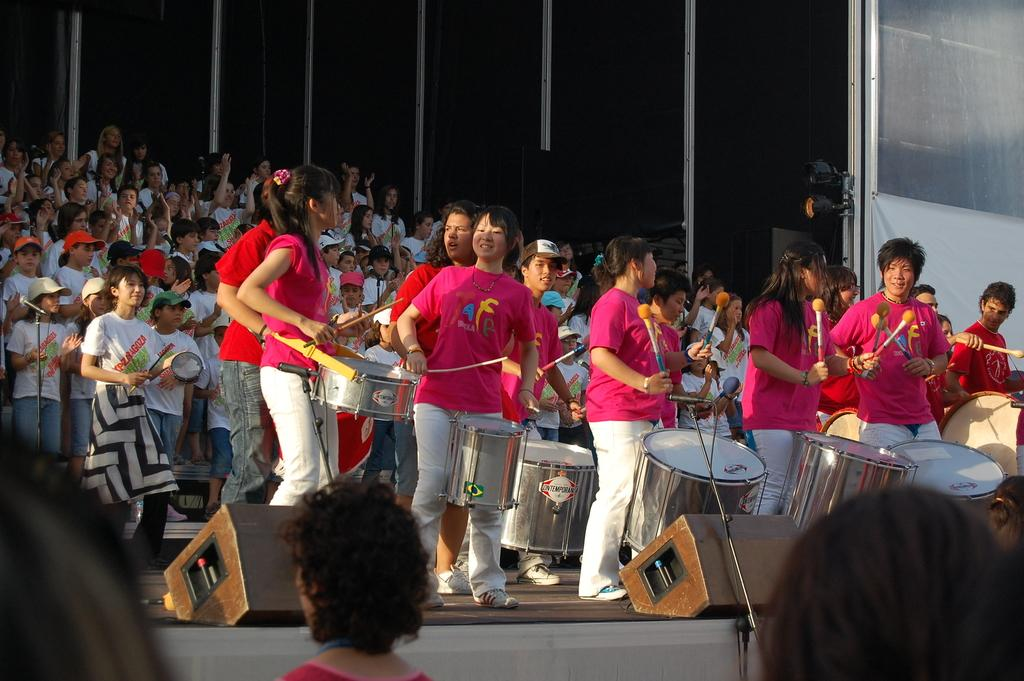What is happening in the image? There is a group of people in the image, and they are playing musical instruments. Where are the people located in the image? The people are on a stage. Reasoning: Let's think step by step by step in order to produce the conversation. We start by identifying the main subject in the image, which is the group of people. Then, we describe what they are doing, which is playing musical instruments. Finally, we mention their location, which is on a stage. Each question is designed to elicit a specific detail about the image that is known from the provided facts. Absurd Question/Answer: What is the size of the body of water visible in the image? There is no body of water visible in the image; it features a group of people playing musical instruments on a stage. How many people are joining the group on stage in the image? There is no indication in the image that more people are joining the group on stage. The image only shows the group of people playing musical instruments on a stage. 